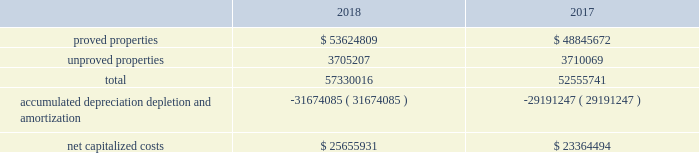Eog resources , inc .
Supplemental information to consolidated financial statements ( continued ) capitalized costs relating to oil and gas producing activities .
The table sets forth the capitalized costs relating to eog's crude oil and natural gas producing activities at december 31 , 2018 and 2017: .
Costs incurred in oil and gas property acquisition , exploration and development activities .
The acquisition , exploration and development costs disclosed in the following tables are in accordance with definitions in the extractive industries - oil and gas topic of the accounting standards codification ( asc ) .
Acquisition costs include costs incurred to purchase , lease or otherwise acquire property .
Exploration costs include additions to exploratory wells , including those in progress , and exploration expenses .
Development costs include additions to production facilities and equipment and additions to development wells , including those in progress. .
What is the variation observed in the accumulated depreciation depletion and amortization between 2017 and 2018? 
Rationale: it is the difference between the accumulated depreciation depletion and amortization of these years .
Computations: (31674085 - 29191247)
Answer: 2482838.0. 